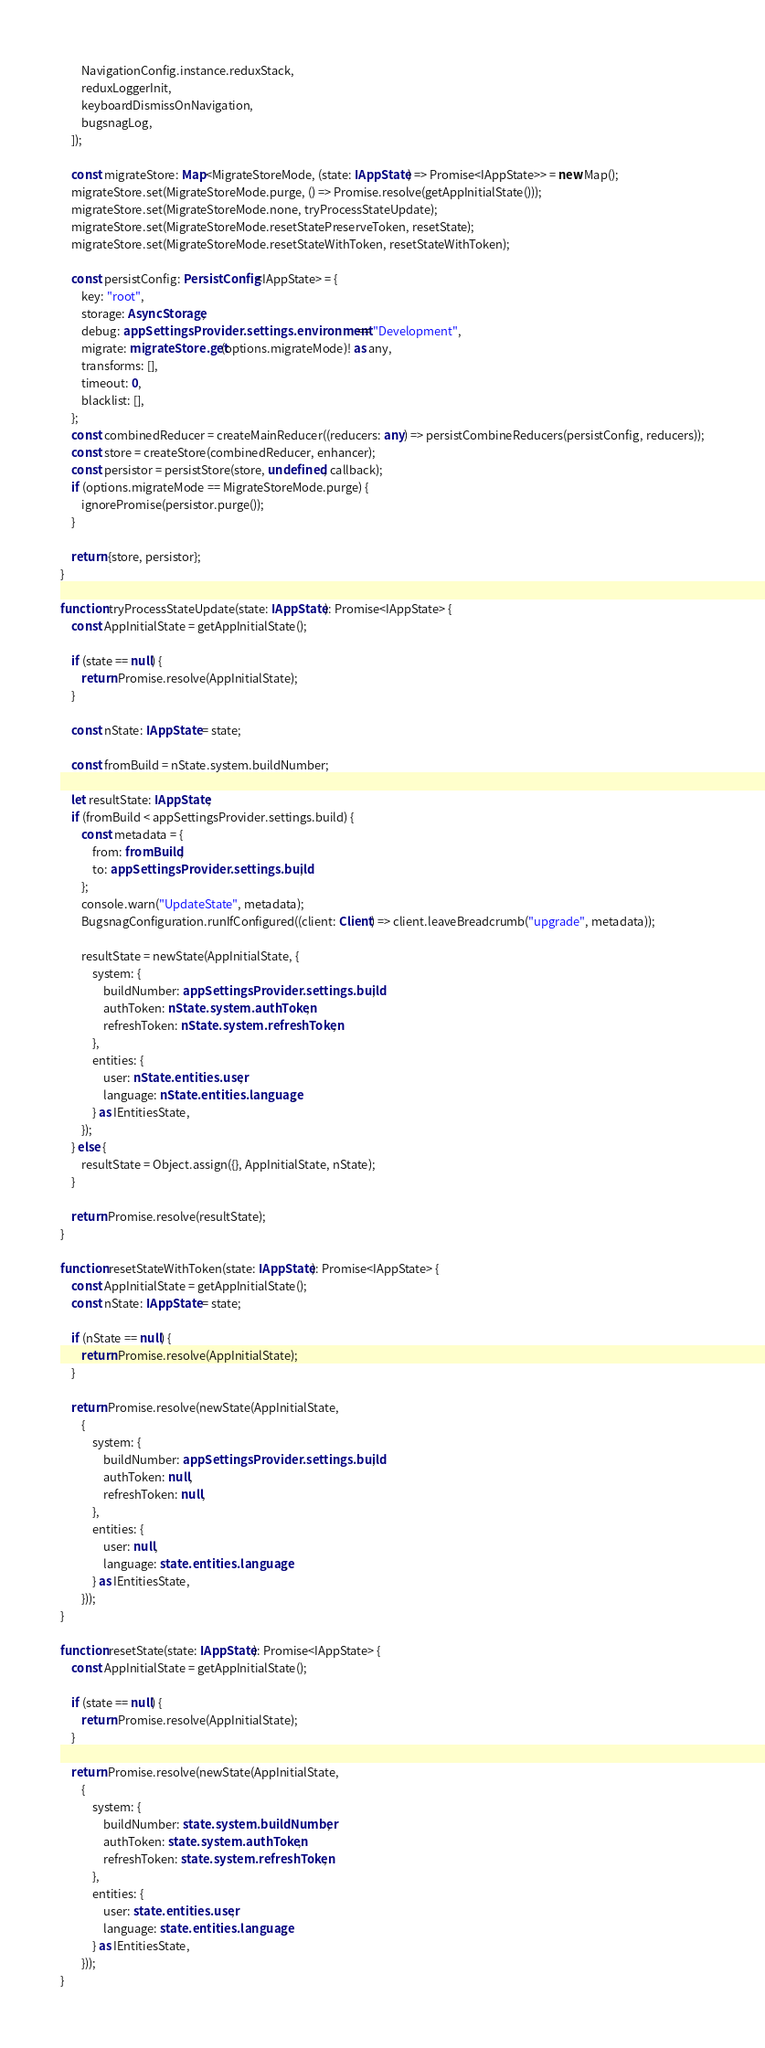<code> <loc_0><loc_0><loc_500><loc_500><_TypeScript_>        NavigationConfig.instance.reduxStack,
        reduxLoggerInit,
        keyboardDismissOnNavigation,
        bugsnagLog,
    ]);

    const migrateStore: Map<MigrateStoreMode, (state: IAppState) => Promise<IAppState>> = new Map();
    migrateStore.set(MigrateStoreMode.purge, () => Promise.resolve(getAppInitialState()));
    migrateStore.set(MigrateStoreMode.none, tryProcessStateUpdate);
    migrateStore.set(MigrateStoreMode.resetStatePreserveToken, resetState);
    migrateStore.set(MigrateStoreMode.resetStateWithToken, resetStateWithToken);

    const persistConfig: PersistConfig<IAppState> = {
        key: "root",
        storage: AsyncStorage,
        debug: appSettingsProvider.settings.environment == "Development",
        migrate: migrateStore.get(options.migrateMode)! as any,
        transforms: [],
        timeout: 0,
        blacklist: [],
    };
    const combinedReducer = createMainReducer((reducers: any) => persistCombineReducers(persistConfig, reducers));
    const store = createStore(combinedReducer, enhancer);
    const persistor = persistStore(store, undefined, callback);
    if (options.migrateMode == MigrateStoreMode.purge) {
        ignorePromise(persistor.purge());
    }

    return {store, persistor};
}

function tryProcessStateUpdate(state: IAppState): Promise<IAppState> {
    const AppInitialState = getAppInitialState();

    if (state == null) {
        return Promise.resolve(AppInitialState);
    }

    const nState: IAppState = state;

    const fromBuild = nState.system.buildNumber;

    let resultState: IAppState;
    if (fromBuild < appSettingsProvider.settings.build) {
        const metadata = {
            from: fromBuild,
            to: appSettingsProvider.settings.build,
        };
        console.warn("UpdateState", metadata);
        BugsnagConfiguration.runIfConfigured((client: Client) => client.leaveBreadcrumb("upgrade", metadata));

        resultState = newState(AppInitialState, {
            system: {
                buildNumber: appSettingsProvider.settings.build,
                authToken: nState.system.authToken,
                refreshToken: nState.system.refreshToken,
            },
            entities: {
                user: nState.entities.user,
                language: nState.entities.language,
            } as IEntitiesState,
        });
    } else {
        resultState = Object.assign({}, AppInitialState, nState);
    }

    return Promise.resolve(resultState);
}

function resetStateWithToken(state: IAppState): Promise<IAppState> {
    const AppInitialState = getAppInitialState();
    const nState: IAppState = state;

    if (nState == null) {
        return Promise.resolve(AppInitialState);
    }

    return Promise.resolve(newState(AppInitialState,
        {
            system: {
                buildNumber: appSettingsProvider.settings.build,
                authToken: null,
                refreshToken: null,
            },
            entities: {
                user: null,
                language: state.entities.language,
            } as IEntitiesState,
        }));
}

function resetState(state: IAppState): Promise<IAppState> {
    const AppInitialState = getAppInitialState();

    if (state == null) {
        return Promise.resolve(AppInitialState);
    }

    return Promise.resolve(newState(AppInitialState,
        {
            system: {
                buildNumber: state.system.buildNumber,
                authToken: state.system.authToken,
                refreshToken: state.system.refreshToken,
            },
            entities: {
                user: state.entities.user,
                language: state.entities.language,
            } as IEntitiesState,
        }));
}</code> 